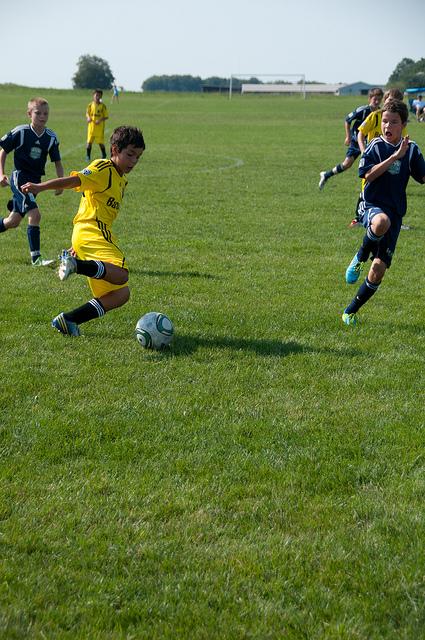How many boys are there?
Give a very brief answer. 6. What color is the shirt of the person who is in control of the ball?
Short answer required. Yellow. What do you call the shoes the players are wearing?
Quick response, please. Cleats. What sport are they playing?
Answer briefly. Soccer. 